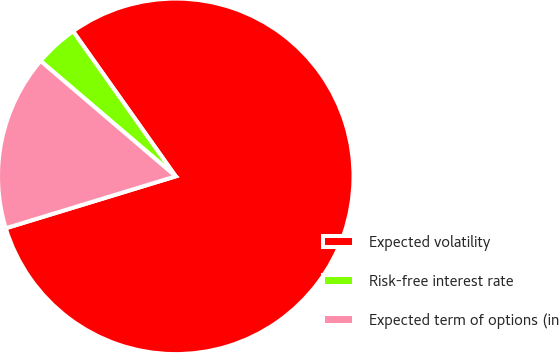Convert chart to OTSL. <chart><loc_0><loc_0><loc_500><loc_500><pie_chart><fcel>Expected volatility<fcel>Risk-free interest rate<fcel>Expected term of options (in<nl><fcel>80.09%<fcel>3.95%<fcel>15.96%<nl></chart> 